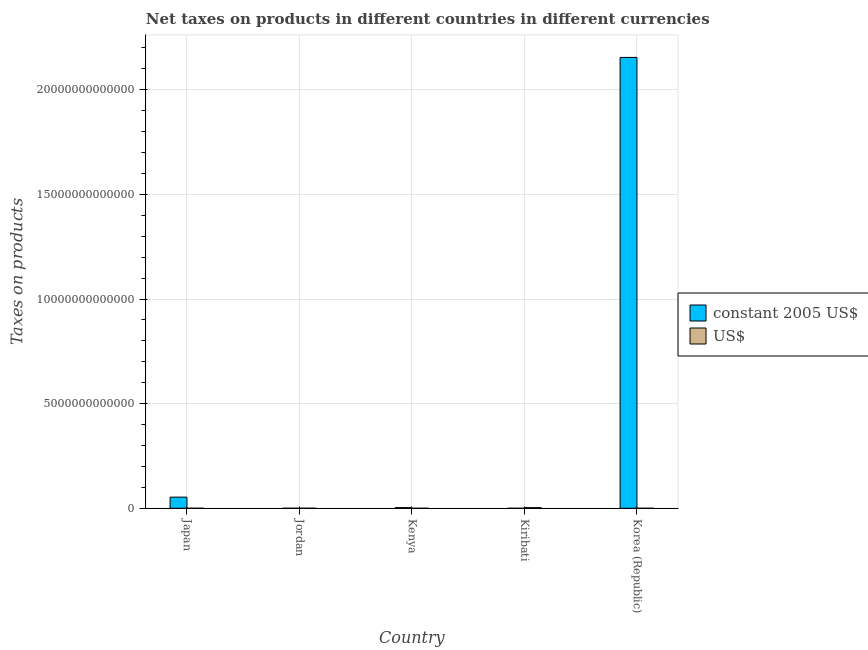How many groups of bars are there?
Offer a very short reply. 5. What is the label of the 2nd group of bars from the left?
Your answer should be very brief. Jordan. What is the net taxes in us$ in Japan?
Provide a short and direct response. 4.78e+08. Across all countries, what is the maximum net taxes in us$?
Ensure brevity in your answer.  2.94e+1. Across all countries, what is the minimum net taxes in us$?
Provide a succinct answer. 2.81e+06. In which country was the net taxes in constant 2005 us$ minimum?
Keep it short and to the point. Kiribati. What is the total net taxes in us$ in the graph?
Offer a very short reply. 3.11e+1. What is the difference between the net taxes in constant 2005 us$ in Kenya and that in Korea (Republic)?
Keep it short and to the point. -2.15e+13. What is the difference between the net taxes in us$ in Kiribati and the net taxes in constant 2005 us$ in Kenya?
Offer a very short reply. -1.06e+09. What is the average net taxes in constant 2005 us$ per country?
Your answer should be very brief. 4.42e+12. What is the difference between the net taxes in constant 2005 us$ and net taxes in us$ in Japan?
Offer a terse response. 5.32e+11. What is the ratio of the net taxes in constant 2005 us$ in Japan to that in Korea (Republic)?
Keep it short and to the point. 0.02. Is the difference between the net taxes in constant 2005 us$ in Jordan and Korea (Republic) greater than the difference between the net taxes in us$ in Jordan and Korea (Republic)?
Ensure brevity in your answer.  No. What is the difference between the highest and the second highest net taxes in constant 2005 us$?
Offer a very short reply. 2.10e+13. What is the difference between the highest and the lowest net taxes in constant 2005 us$?
Provide a succinct answer. 2.15e+13. What does the 2nd bar from the left in Jordan represents?
Offer a terse response. US$. What does the 1st bar from the right in Kenya represents?
Provide a succinct answer. US$. How many bars are there?
Ensure brevity in your answer.  10. Are all the bars in the graph horizontal?
Provide a short and direct response. No. How many countries are there in the graph?
Your answer should be compact. 5. What is the difference between two consecutive major ticks on the Y-axis?
Provide a succinct answer. 5.00e+12. Are the values on the major ticks of Y-axis written in scientific E-notation?
Keep it short and to the point. No. Does the graph contain grids?
Your response must be concise. Yes. Where does the legend appear in the graph?
Your answer should be very brief. Center right. How many legend labels are there?
Your answer should be compact. 2. What is the title of the graph?
Your answer should be compact. Net taxes on products in different countries in different currencies. Does "Lowest 10% of population" appear as one of the legend labels in the graph?
Your answer should be compact. No. What is the label or title of the Y-axis?
Offer a very short reply. Taxes on products. What is the Taxes on products in constant 2005 US$ in Japan?
Offer a terse response. 5.32e+11. What is the Taxes on products in US$ in Japan?
Make the answer very short. 4.78e+08. What is the Taxes on products of constant 2005 US$ in Jordan?
Provide a short and direct response. 3.25e+08. What is the Taxes on products in US$ in Jordan?
Ensure brevity in your answer.  1.11e+09. What is the Taxes on products of constant 2005 US$ in Kenya?
Ensure brevity in your answer.  3.04e+1. What is the Taxes on products of US$ in Kenya?
Give a very brief answer. 2.81e+06. What is the Taxes on products of constant 2005 US$ in Kiribati?
Make the answer very short. 3.60e+06. What is the Taxes on products of US$ in Kiribati?
Make the answer very short. 2.94e+1. What is the Taxes on products of constant 2005 US$ in Korea (Republic)?
Offer a terse response. 2.15e+13. What is the Taxes on products of US$ in Korea (Republic)?
Offer a terse response. 1.20e+08. Across all countries, what is the maximum Taxes on products of constant 2005 US$?
Your answer should be compact. 2.15e+13. Across all countries, what is the maximum Taxes on products of US$?
Your response must be concise. 2.94e+1. Across all countries, what is the minimum Taxes on products of constant 2005 US$?
Offer a very short reply. 3.60e+06. Across all countries, what is the minimum Taxes on products of US$?
Ensure brevity in your answer.  2.81e+06. What is the total Taxes on products in constant 2005 US$ in the graph?
Give a very brief answer. 2.21e+13. What is the total Taxes on products of US$ in the graph?
Offer a very short reply. 3.11e+1. What is the difference between the Taxes on products of constant 2005 US$ in Japan and that in Jordan?
Keep it short and to the point. 5.32e+11. What is the difference between the Taxes on products in US$ in Japan and that in Jordan?
Make the answer very short. -6.29e+08. What is the difference between the Taxes on products in constant 2005 US$ in Japan and that in Kenya?
Ensure brevity in your answer.  5.02e+11. What is the difference between the Taxes on products of US$ in Japan and that in Kenya?
Ensure brevity in your answer.  4.75e+08. What is the difference between the Taxes on products in constant 2005 US$ in Japan and that in Kiribati?
Give a very brief answer. 5.32e+11. What is the difference between the Taxes on products of US$ in Japan and that in Kiribati?
Provide a succinct answer. -2.89e+1. What is the difference between the Taxes on products in constant 2005 US$ in Japan and that in Korea (Republic)?
Provide a succinct answer. -2.10e+13. What is the difference between the Taxes on products of US$ in Japan and that in Korea (Republic)?
Give a very brief answer. 3.58e+08. What is the difference between the Taxes on products of constant 2005 US$ in Jordan and that in Kenya?
Keep it short and to the point. -3.01e+1. What is the difference between the Taxes on products in US$ in Jordan and that in Kenya?
Keep it short and to the point. 1.10e+09. What is the difference between the Taxes on products in constant 2005 US$ in Jordan and that in Kiribati?
Ensure brevity in your answer.  3.22e+08. What is the difference between the Taxes on products in US$ in Jordan and that in Kiribati?
Your answer should be very brief. -2.83e+1. What is the difference between the Taxes on products of constant 2005 US$ in Jordan and that in Korea (Republic)?
Your answer should be compact. -2.15e+13. What is the difference between the Taxes on products of US$ in Jordan and that in Korea (Republic)?
Provide a short and direct response. 9.87e+08. What is the difference between the Taxes on products of constant 2005 US$ in Kenya and that in Kiribati?
Your response must be concise. 3.04e+1. What is the difference between the Taxes on products in US$ in Kenya and that in Kiribati?
Offer a terse response. -2.94e+1. What is the difference between the Taxes on products in constant 2005 US$ in Kenya and that in Korea (Republic)?
Your answer should be compact. -2.15e+13. What is the difference between the Taxes on products of US$ in Kenya and that in Korea (Republic)?
Make the answer very short. -1.17e+08. What is the difference between the Taxes on products of constant 2005 US$ in Kiribati and that in Korea (Republic)?
Your answer should be compact. -2.15e+13. What is the difference between the Taxes on products in US$ in Kiribati and that in Korea (Republic)?
Offer a very short reply. 2.93e+1. What is the difference between the Taxes on products of constant 2005 US$ in Japan and the Taxes on products of US$ in Jordan?
Provide a succinct answer. 5.31e+11. What is the difference between the Taxes on products in constant 2005 US$ in Japan and the Taxes on products in US$ in Kenya?
Your response must be concise. 5.32e+11. What is the difference between the Taxes on products in constant 2005 US$ in Japan and the Taxes on products in US$ in Kiribati?
Your response must be concise. 5.03e+11. What is the difference between the Taxes on products of constant 2005 US$ in Japan and the Taxes on products of US$ in Korea (Republic)?
Give a very brief answer. 5.32e+11. What is the difference between the Taxes on products in constant 2005 US$ in Jordan and the Taxes on products in US$ in Kenya?
Your response must be concise. 3.23e+08. What is the difference between the Taxes on products in constant 2005 US$ in Jordan and the Taxes on products in US$ in Kiribati?
Ensure brevity in your answer.  -2.91e+1. What is the difference between the Taxes on products in constant 2005 US$ in Jordan and the Taxes on products in US$ in Korea (Republic)?
Your response must be concise. 2.06e+08. What is the difference between the Taxes on products of constant 2005 US$ in Kenya and the Taxes on products of US$ in Kiribati?
Offer a very short reply. 1.06e+09. What is the difference between the Taxes on products in constant 2005 US$ in Kenya and the Taxes on products in US$ in Korea (Republic)?
Offer a terse response. 3.03e+1. What is the difference between the Taxes on products of constant 2005 US$ in Kiribati and the Taxes on products of US$ in Korea (Republic)?
Keep it short and to the point. -1.16e+08. What is the average Taxes on products in constant 2005 US$ per country?
Keep it short and to the point. 4.42e+12. What is the average Taxes on products in US$ per country?
Your response must be concise. 6.22e+09. What is the difference between the Taxes on products in constant 2005 US$ and Taxes on products in US$ in Japan?
Keep it short and to the point. 5.32e+11. What is the difference between the Taxes on products of constant 2005 US$ and Taxes on products of US$ in Jordan?
Offer a very short reply. -7.81e+08. What is the difference between the Taxes on products in constant 2005 US$ and Taxes on products in US$ in Kenya?
Keep it short and to the point. 3.04e+1. What is the difference between the Taxes on products of constant 2005 US$ and Taxes on products of US$ in Kiribati?
Make the answer very short. -2.94e+1. What is the difference between the Taxes on products in constant 2005 US$ and Taxes on products in US$ in Korea (Republic)?
Provide a short and direct response. 2.15e+13. What is the ratio of the Taxes on products of constant 2005 US$ in Japan to that in Jordan?
Provide a short and direct response. 1636.28. What is the ratio of the Taxes on products in US$ in Japan to that in Jordan?
Your response must be concise. 0.43. What is the ratio of the Taxes on products in constant 2005 US$ in Japan to that in Kenya?
Provide a short and direct response. 17.49. What is the ratio of the Taxes on products in US$ in Japan to that in Kenya?
Your answer should be very brief. 170.29. What is the ratio of the Taxes on products of constant 2005 US$ in Japan to that in Kiribati?
Your response must be concise. 1.48e+05. What is the ratio of the Taxes on products of US$ in Japan to that in Kiribati?
Provide a succinct answer. 0.02. What is the ratio of the Taxes on products of constant 2005 US$ in Japan to that in Korea (Republic)?
Ensure brevity in your answer.  0.02. What is the ratio of the Taxes on products in US$ in Japan to that in Korea (Republic)?
Keep it short and to the point. 4. What is the ratio of the Taxes on products of constant 2005 US$ in Jordan to that in Kenya?
Provide a succinct answer. 0.01. What is the ratio of the Taxes on products in US$ in Jordan to that in Kenya?
Offer a terse response. 394.32. What is the ratio of the Taxes on products of constant 2005 US$ in Jordan to that in Kiribati?
Offer a very short reply. 90.31. What is the ratio of the Taxes on products of US$ in Jordan to that in Kiribati?
Offer a very short reply. 0.04. What is the ratio of the Taxes on products in US$ in Jordan to that in Korea (Republic)?
Your answer should be compact. 9.25. What is the ratio of the Taxes on products in constant 2005 US$ in Kenya to that in Kiribati?
Your answer should be very brief. 8449.07. What is the ratio of the Taxes on products in US$ in Kenya to that in Kiribati?
Your answer should be compact. 0. What is the ratio of the Taxes on products of constant 2005 US$ in Kenya to that in Korea (Republic)?
Ensure brevity in your answer.  0. What is the ratio of the Taxes on products in US$ in Kenya to that in Korea (Republic)?
Ensure brevity in your answer.  0.02. What is the ratio of the Taxes on products in constant 2005 US$ in Kiribati to that in Korea (Republic)?
Your response must be concise. 0. What is the ratio of the Taxes on products in US$ in Kiribati to that in Korea (Republic)?
Your response must be concise. 245.7. What is the difference between the highest and the second highest Taxes on products in constant 2005 US$?
Your answer should be very brief. 2.10e+13. What is the difference between the highest and the second highest Taxes on products of US$?
Your answer should be very brief. 2.83e+1. What is the difference between the highest and the lowest Taxes on products in constant 2005 US$?
Your answer should be compact. 2.15e+13. What is the difference between the highest and the lowest Taxes on products of US$?
Offer a terse response. 2.94e+1. 